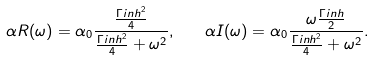<formula> <loc_0><loc_0><loc_500><loc_500>\alpha R ( \omega ) = \alpha _ { 0 } \frac { \frac { \Gamma i n h ^ { 2 } } { 4 } } { \frac { \Gamma i n h ^ { 2 } } { 4 } + \omega ^ { 2 } } , \quad \alpha I ( \omega ) = \alpha _ { 0 } \frac { \omega \frac { \Gamma i n h } { 2 } } { \frac { \Gamma i n h ^ { 2 } } { 4 } + \omega ^ { 2 } } .</formula> 